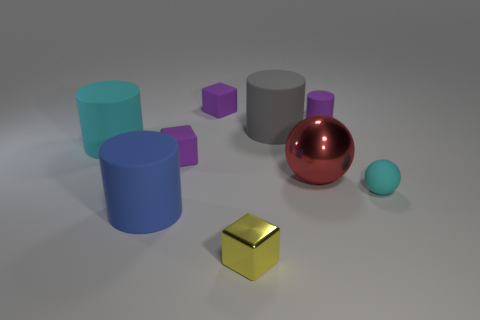What shape is the red object that is the same size as the blue object?
Provide a succinct answer. Sphere. What number of matte things are both to the left of the gray rubber cylinder and right of the yellow metal cube?
Your answer should be very brief. 0. Is the number of things that are to the right of the small yellow object less than the number of small cyan matte spheres?
Your answer should be very brief. No. Are there any red matte balls of the same size as the red shiny thing?
Your answer should be compact. No. What color is the small block that is the same material as the big sphere?
Your response must be concise. Yellow. There is a sphere that is in front of the red metal ball; how many small blocks are left of it?
Provide a succinct answer. 3. There is a tiny object that is on the left side of the large gray cylinder and in front of the large red thing; what material is it?
Offer a very short reply. Metal. There is a small purple object that is to the right of the small yellow object; does it have the same shape as the gray rubber object?
Your answer should be compact. Yes. Is the number of big things less than the number of small matte cubes?
Make the answer very short. No. How many things are the same color as the tiny matte ball?
Offer a terse response. 1. 